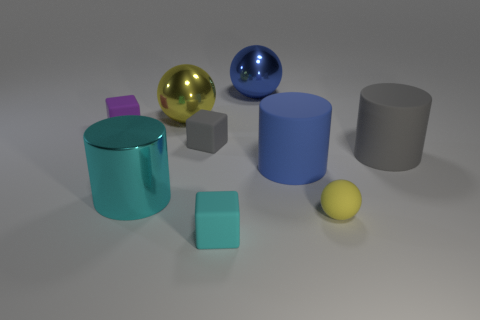Subtract all purple cylinders. Subtract all blue spheres. How many cylinders are left? 3 Add 1 tiny matte cylinders. How many objects exist? 10 Subtract all blocks. How many objects are left? 6 Subtract 1 gray cubes. How many objects are left? 8 Subtract all large yellow metallic spheres. Subtract all large cylinders. How many objects are left? 5 Add 1 large blue metallic spheres. How many large blue metallic spheres are left? 2 Add 4 blue cylinders. How many blue cylinders exist? 5 